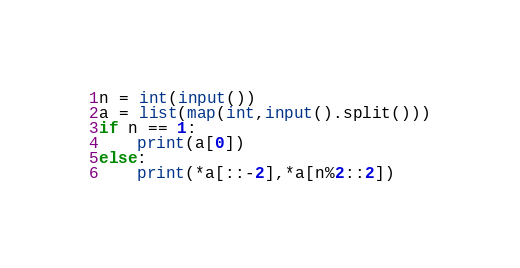<code> <loc_0><loc_0><loc_500><loc_500><_Python_>n = int(input())
a = list(map(int,input().split()))
if n == 1:
    print(a[0])
else:
    print(*a[::-2],*a[n%2::2])</code> 